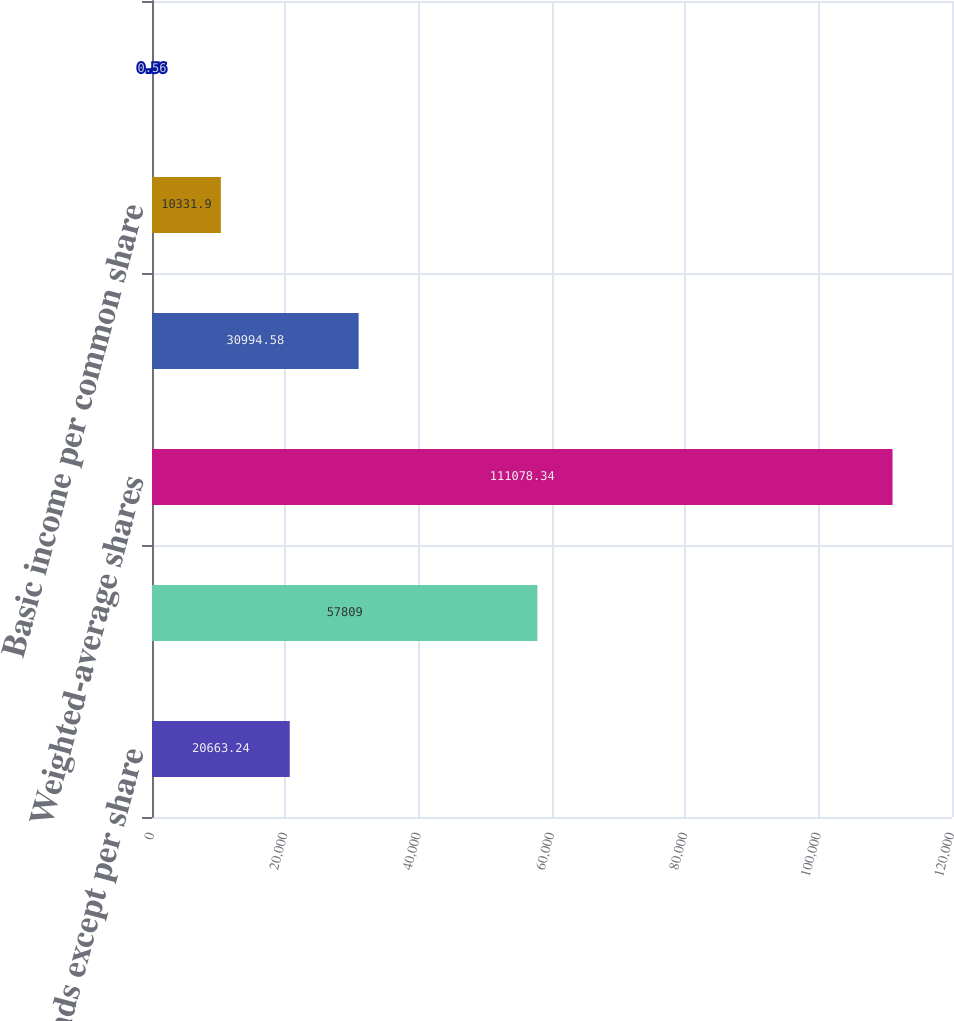Convert chart. <chart><loc_0><loc_0><loc_500><loc_500><bar_chart><fcel>(in thousands except per share<fcel>Basic and diluted earnings<fcel>Weighted-average shares<fcel>Employee Stock Options<fcel>Basic income per common share<fcel>Diluted income per common<nl><fcel>20663.2<fcel>57809<fcel>111078<fcel>30994.6<fcel>10331.9<fcel>0.56<nl></chart> 